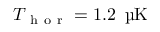<formula> <loc_0><loc_0><loc_500><loc_500>T _ { h o r } = 1 . 2 \, \text  mu K</formula> 